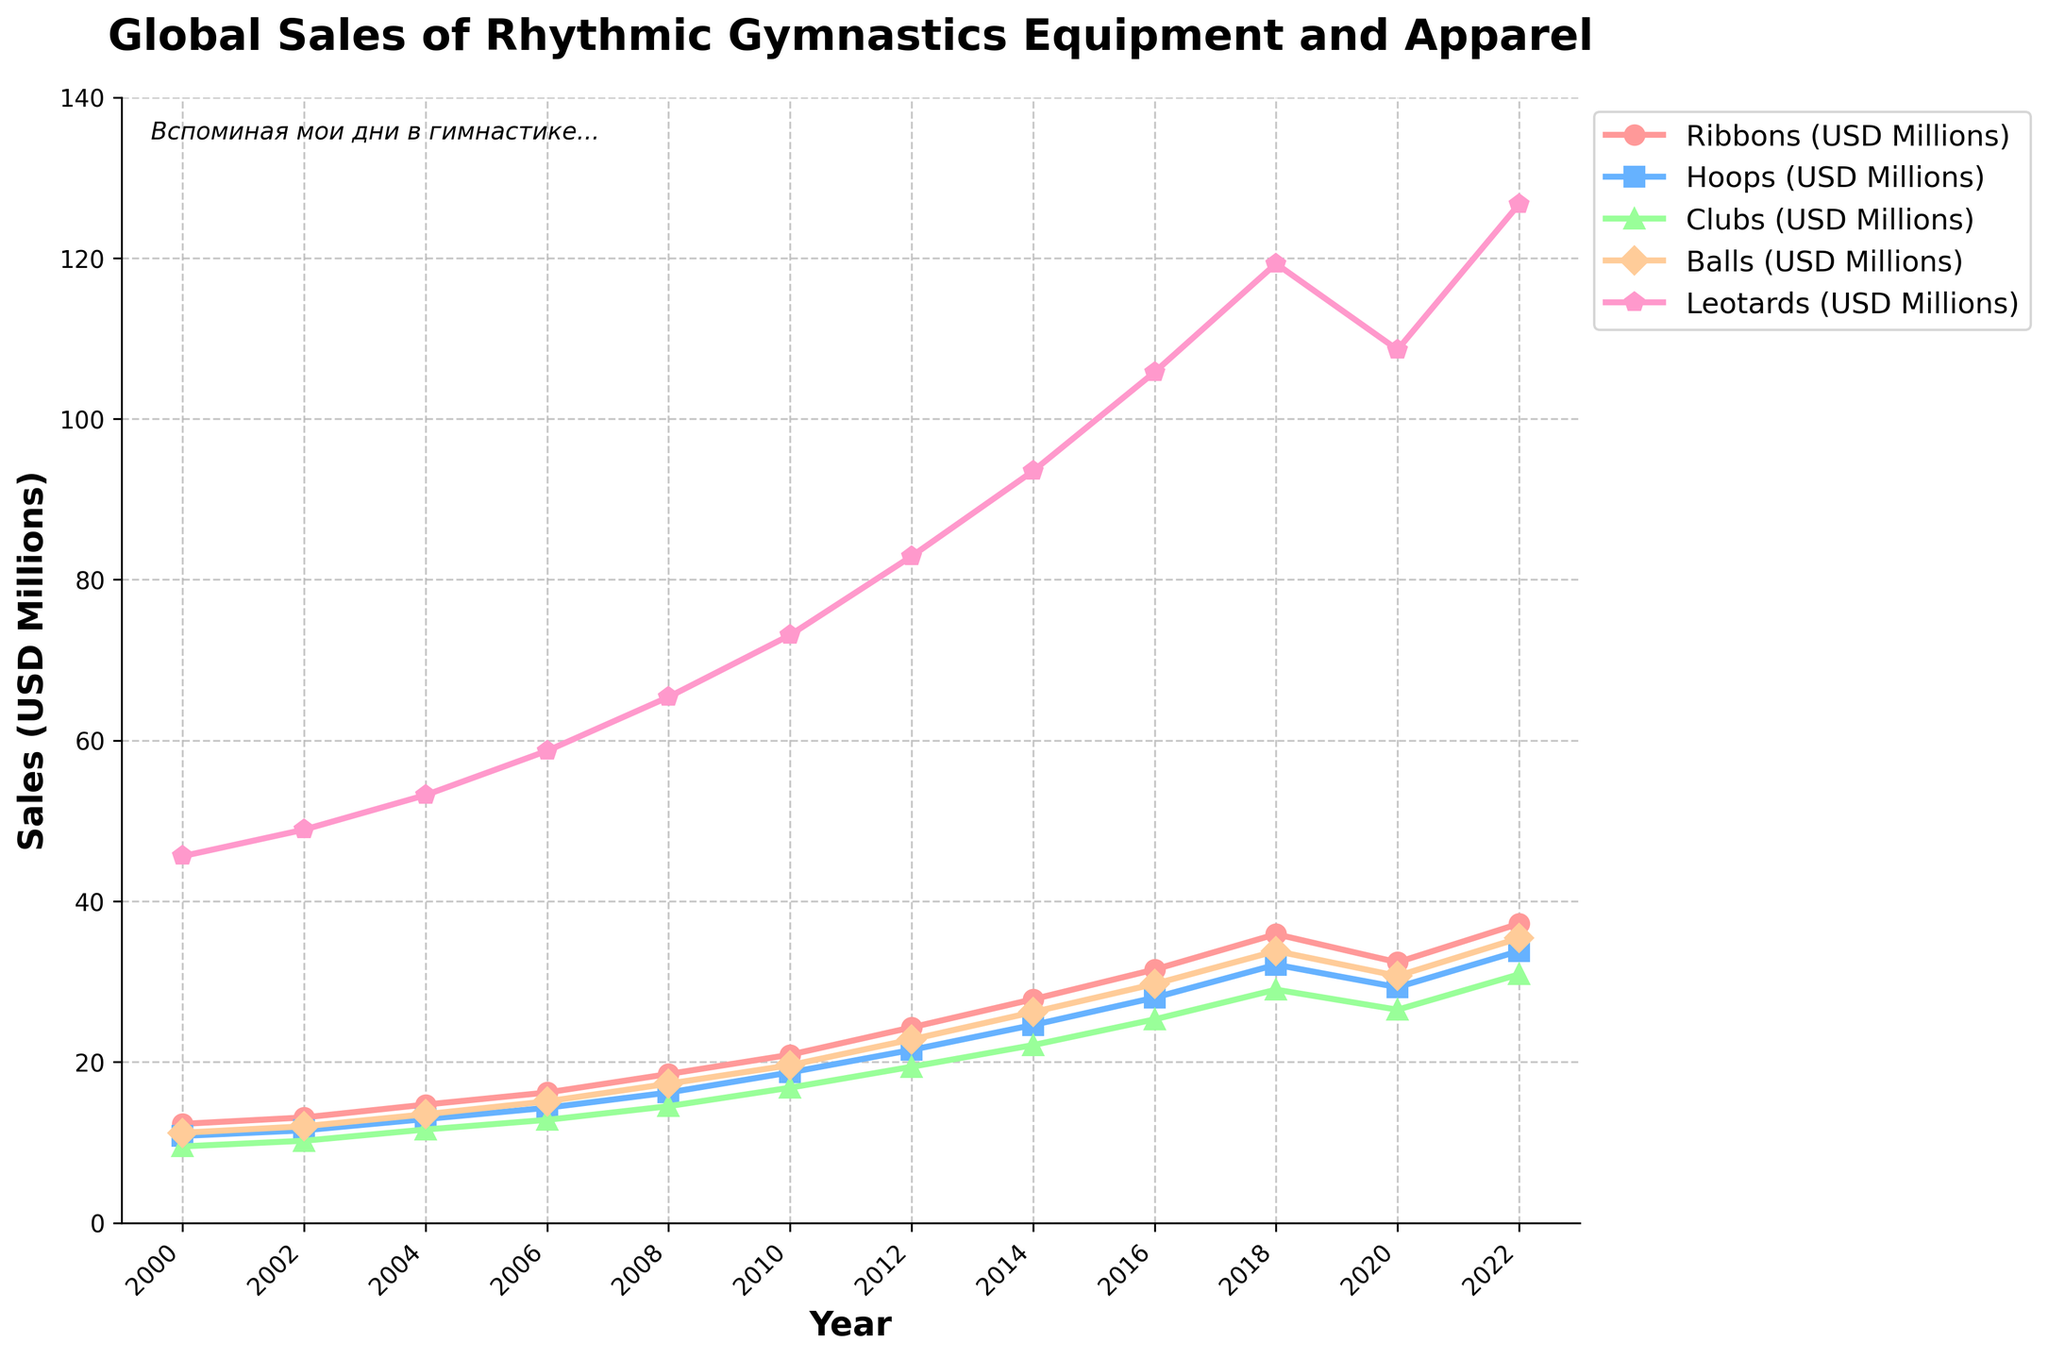what was the sales trend for Leotards between 2000 and 2022? Between 2000 and 2022, the sales of Leotards consistently increased each year except for a slight dip in 2020. The sales grew from 45.6 million USD in 2000 to 126.7 million USD in 2022.
Answer: Consistent increase with a slight dip in 2020 Which year saw the highest sales for Balls? To find the year with the highest sales for Balls, look at the plot line for Balls. The highest point is in 2022 at 35.4 million USD.
Answer: 2022 How did the sales of Clubs in 2022 compare to those in 2000? To compare, note that the sales of Clubs were 9.5 million USD in 2000 and 30.9 million USD in 2022.
Answer: Increased from 9.5 to 30.9 million USD In which year did Ribbons surpass the 20 million USD mark? Check the sales line for Ribbons. It surpassed 20 million USD in the year 2010, reaching 20.9 million USD.
Answer: 2010 What is the average sales value for Hoops between 2000 and 2022? To find the average, sum the sales from 2000 to 2022 and divide by the number of years. (10.8 + 11.5 + 12.9 + 14.3 + 16.2 + 18.7 + 21.5 + 24.6 + 28.0 + 32.1 + 29.3 + 33.8) / 12 = 21.325 million USD.
Answer: 21.325 million USD 